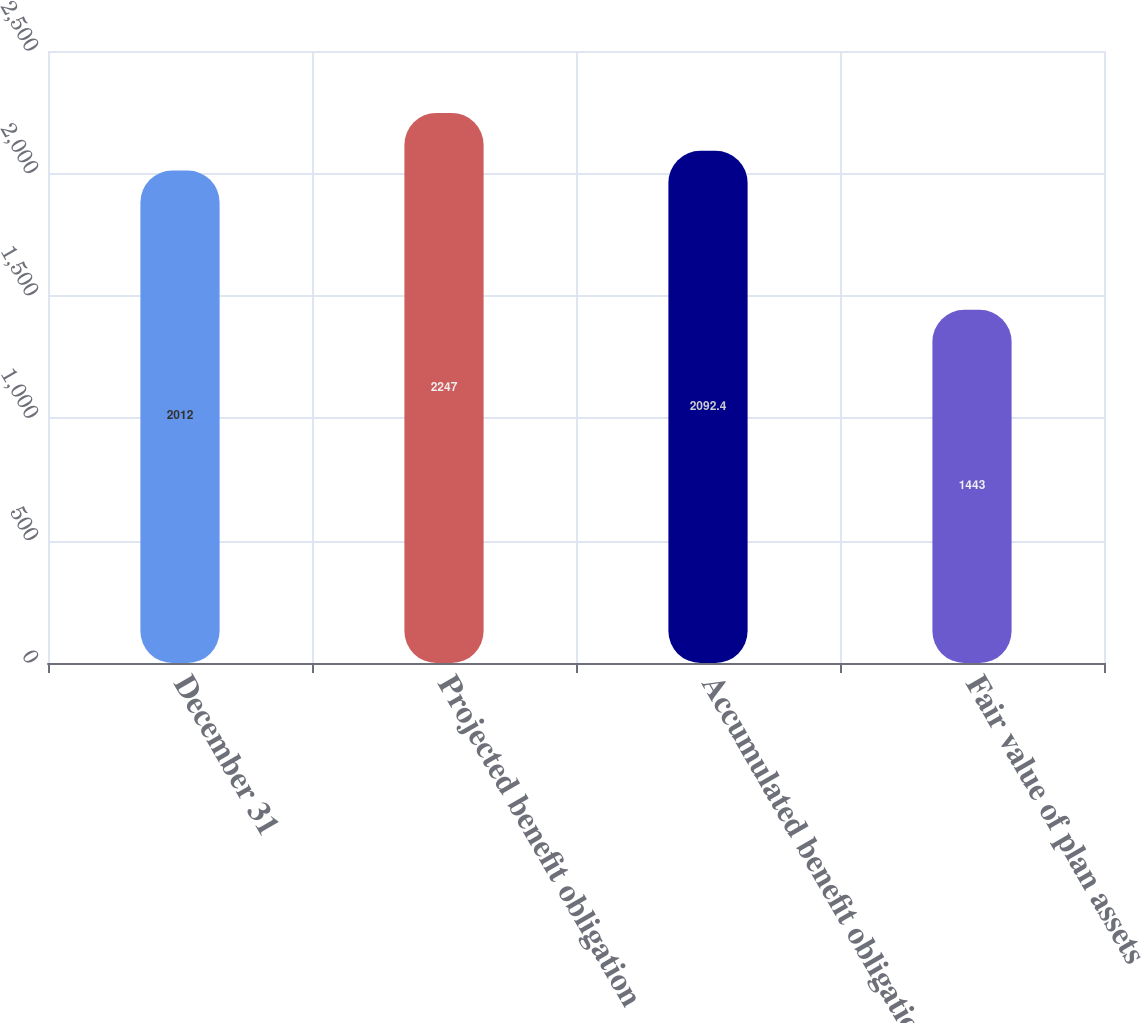<chart> <loc_0><loc_0><loc_500><loc_500><bar_chart><fcel>December 31<fcel>Projected benefit obligation<fcel>Accumulated benefit obligation<fcel>Fair value of plan assets<nl><fcel>2012<fcel>2247<fcel>2092.4<fcel>1443<nl></chart> 